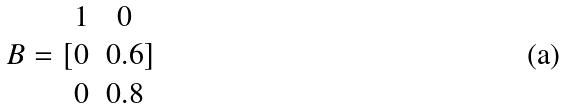Convert formula to latex. <formula><loc_0><loc_0><loc_500><loc_500>B = [ \begin{matrix} 1 & 0 \\ 0 & 0 . 6 \\ 0 & 0 . 8 \end{matrix} ]</formula> 